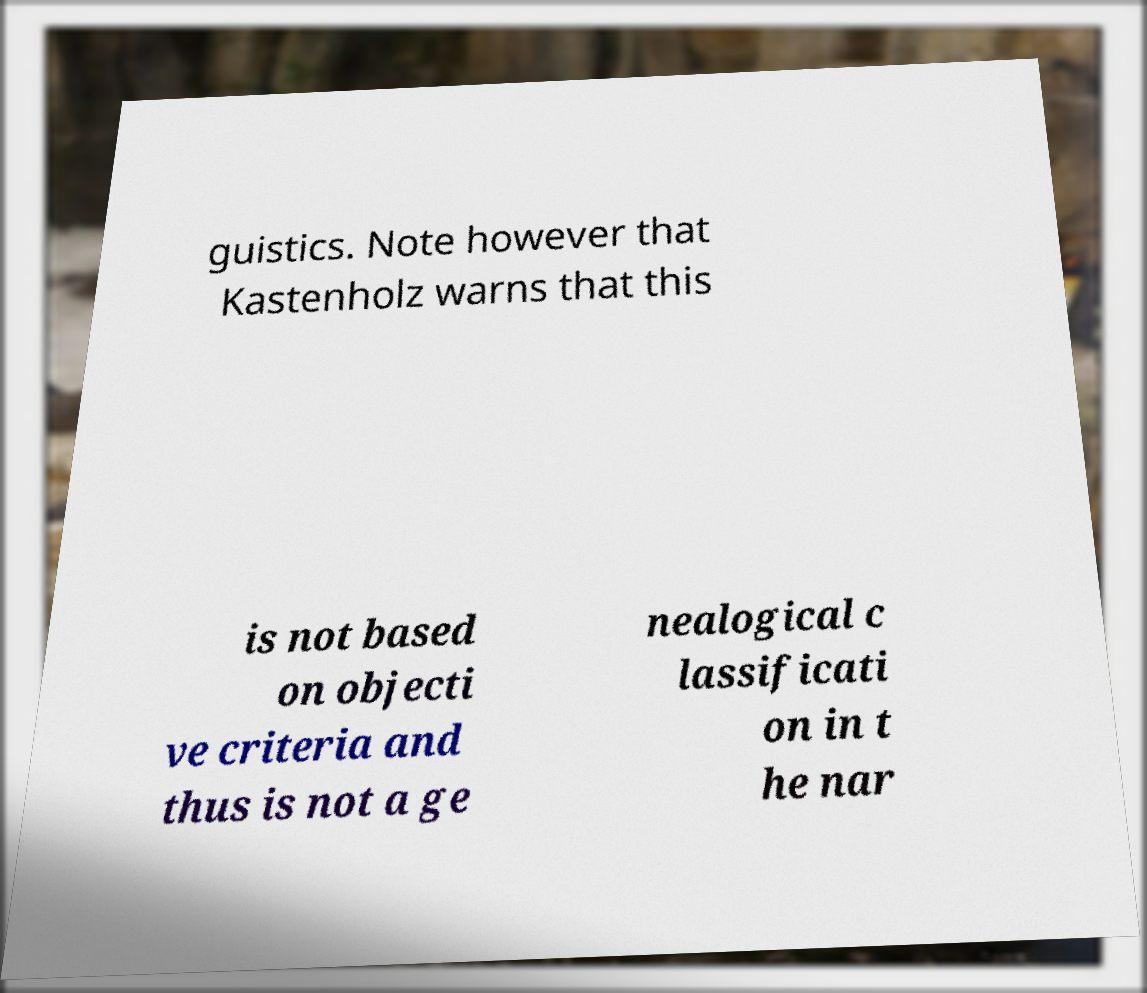Could you assist in decoding the text presented in this image and type it out clearly? guistics. Note however that Kastenholz warns that this is not based on objecti ve criteria and thus is not a ge nealogical c lassificati on in t he nar 